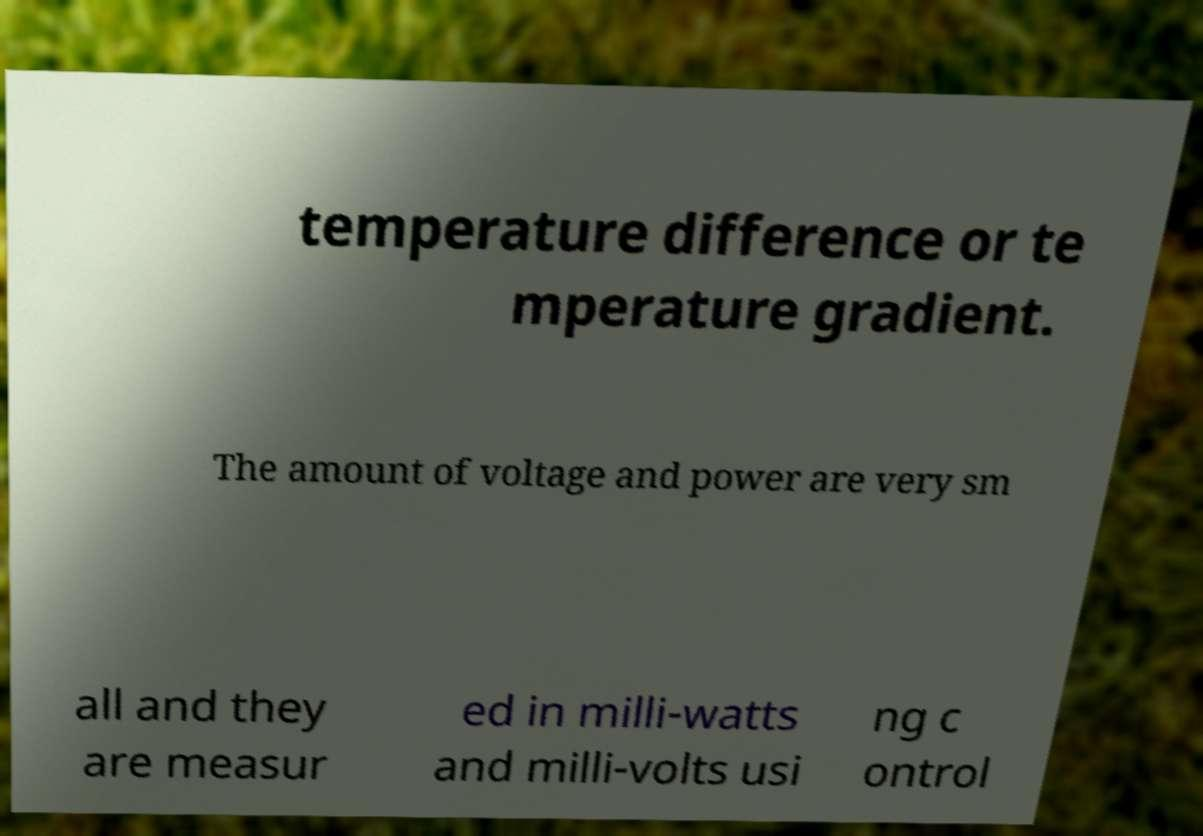There's text embedded in this image that I need extracted. Can you transcribe it verbatim? temperature difference or te mperature gradient. The amount of voltage and power are very sm all and they are measur ed in milli-watts and milli-volts usi ng c ontrol 